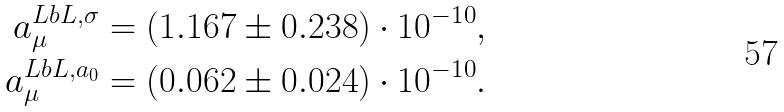Convert formula to latex. <formula><loc_0><loc_0><loc_500><loc_500>a _ { \mu } ^ { L b L , \sigma } & = ( 1 . 1 6 7 \pm 0 . 2 3 8 ) \cdot 1 0 ^ { - 1 0 } , \\ a _ { \mu } ^ { L b L , a _ { 0 } } & = ( 0 . 0 6 2 \pm 0 . 0 2 4 ) \cdot 1 0 ^ { - 1 0 } .</formula> 